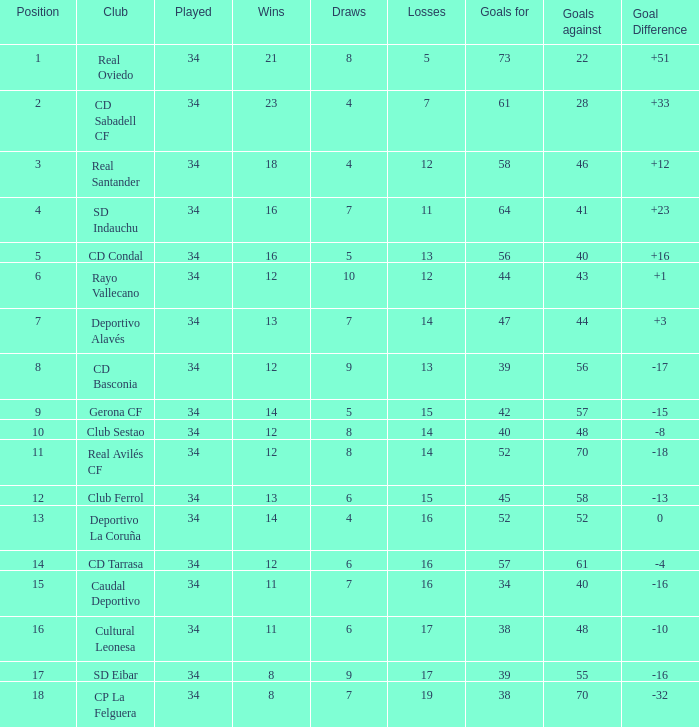Which Played has Draws smaller than 7, and Goals for smaller than 61, and Goals against smaller than 48, and a Position of 5? 34.0. 